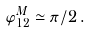Convert formula to latex. <formula><loc_0><loc_0><loc_500><loc_500>\varphi _ { 1 2 } ^ { M } \simeq \pi / 2 \, .</formula> 